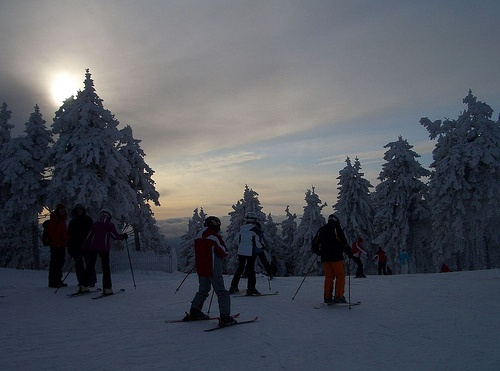Describe the objects in this image and their specific colors. I can see people in gray and black tones, people in black and gray tones, people in gray, black, and darkblue tones, people in gray, black, navy, and darkblue tones, and people in gray, black, and darkblue tones in this image. 